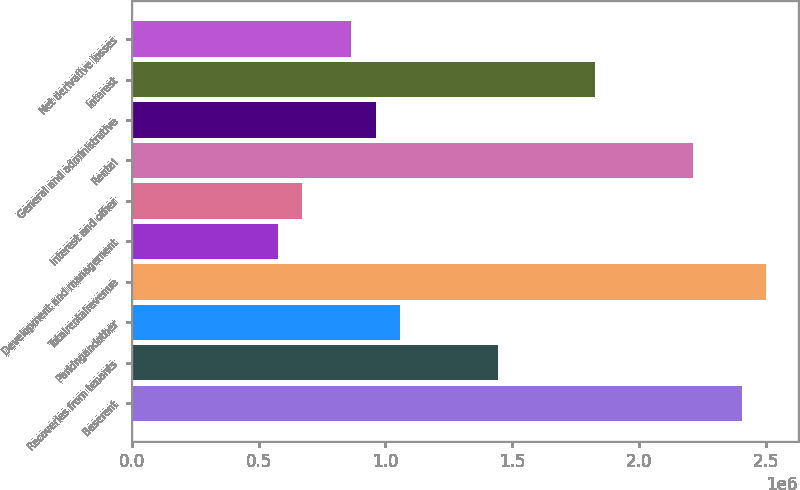<chart> <loc_0><loc_0><loc_500><loc_500><bar_chart><fcel>Baserent<fcel>Recoveries from tenants<fcel>Parkingandother<fcel>Totalrentalrevenue<fcel>Development and management<fcel>Interest and other<fcel>Rental<fcel>General and administrative<fcel>Interest<fcel>Net derivative losses<nl><fcel>2.40292e+06<fcel>1.44175e+06<fcel>1.05729e+06<fcel>2.49904e+06<fcel>576701<fcel>672818<fcel>2.21069e+06<fcel>961169<fcel>1.82622e+06<fcel>865052<nl></chart> 